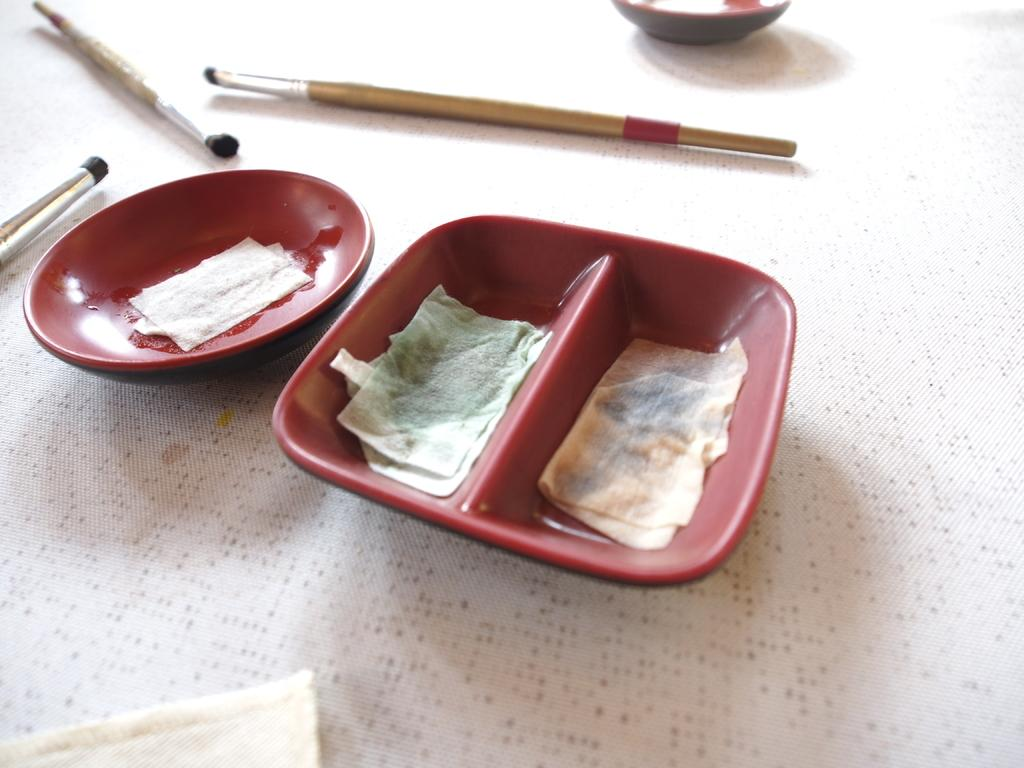How many containers are visible in the image? There are two containers in the image. What can be found on the cloth in the image? There are paint brushes on a cloth in the image. What type of trip is the father planning with the scale in the image? There is no father or scale present in the image; it only features two containers and paint brushes on a cloth. 